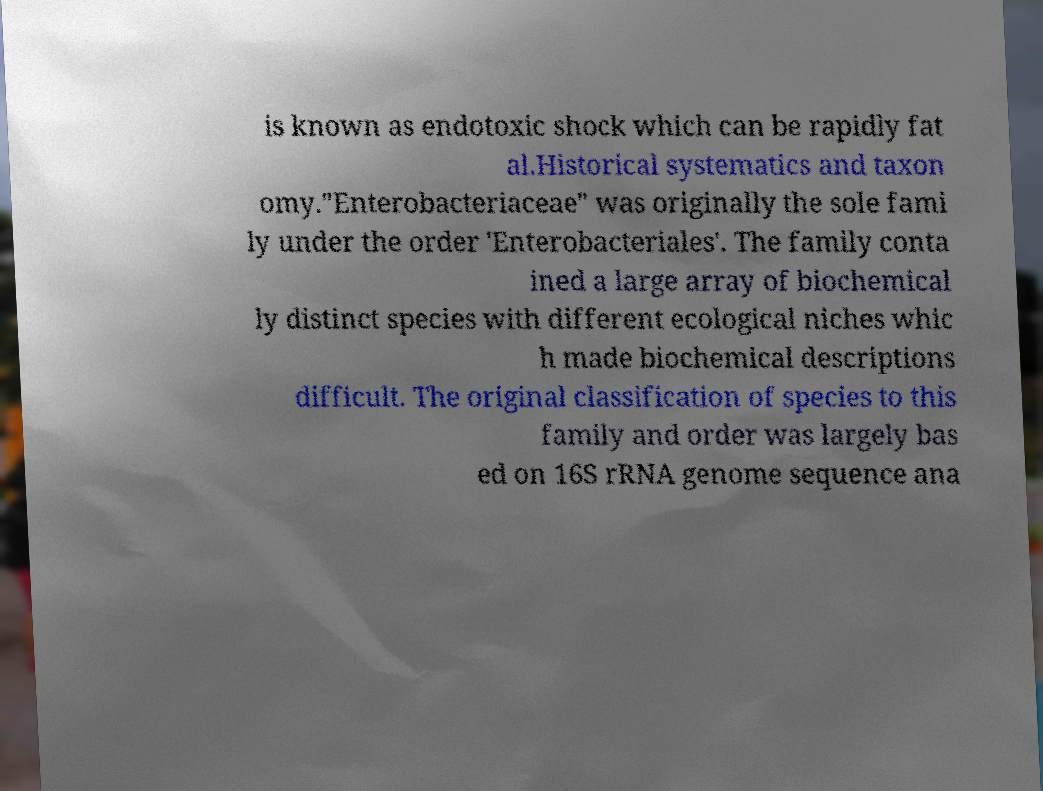There's text embedded in this image that I need extracted. Can you transcribe it verbatim? is known as endotoxic shock which can be rapidly fat al.Historical systematics and taxon omy."Enterobacteriaceae" was originally the sole fami ly under the order 'Enterobacteriales'. The family conta ined a large array of biochemical ly distinct species with different ecological niches whic h made biochemical descriptions difficult. The original classification of species to this family and order was largely bas ed on 16S rRNA genome sequence ana 